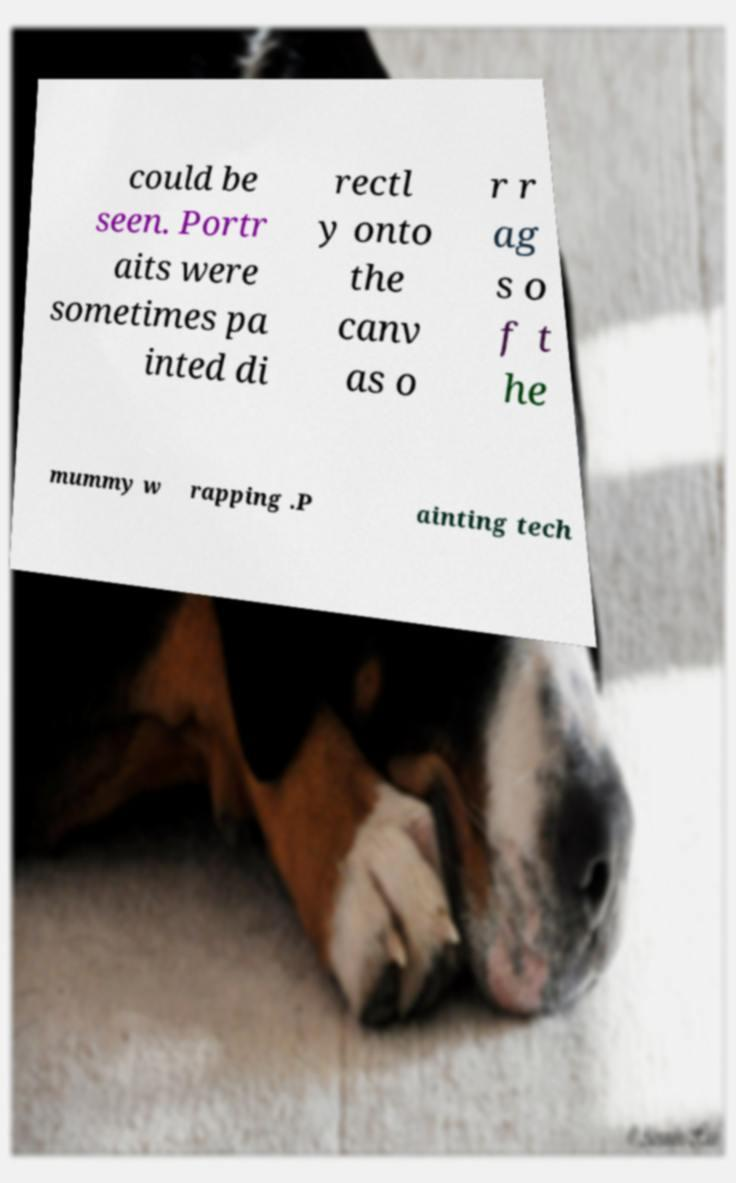I need the written content from this picture converted into text. Can you do that? could be seen. Portr aits were sometimes pa inted di rectl y onto the canv as o r r ag s o f t he mummy w rapping .P ainting tech 